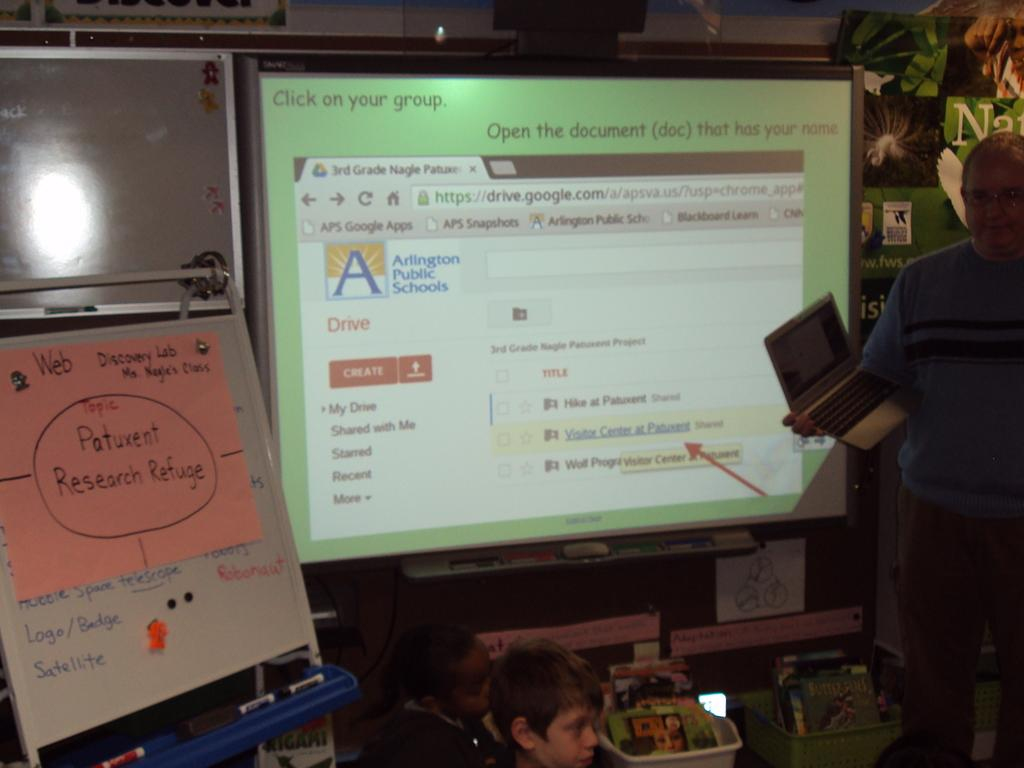Provide a one-sentence caption for the provided image. An arlington public school google drive page is shown on the projector. 